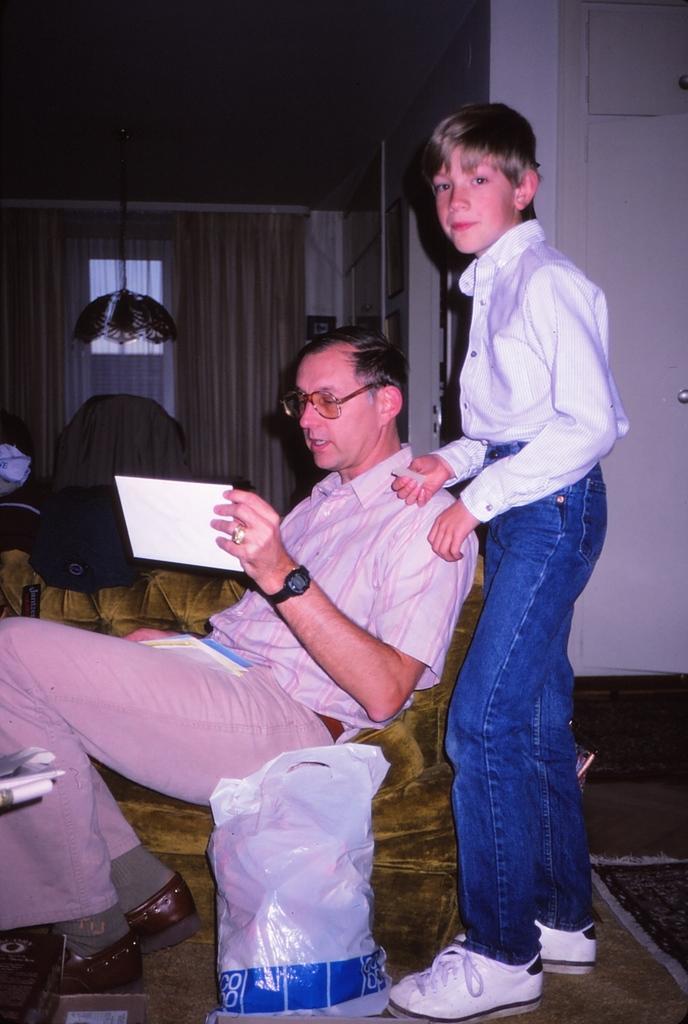Describe this image in one or two sentences. In this image, I can see a boy standing. This is the man holding a paper and sitting on the couch. This looks like a bag, which is kept on the floor. I can see a lamp hanging to the ceiling. In the background, these look like the curtains hanging to a hanger. On the right side of the image, It looks like a door, which is white in color. 